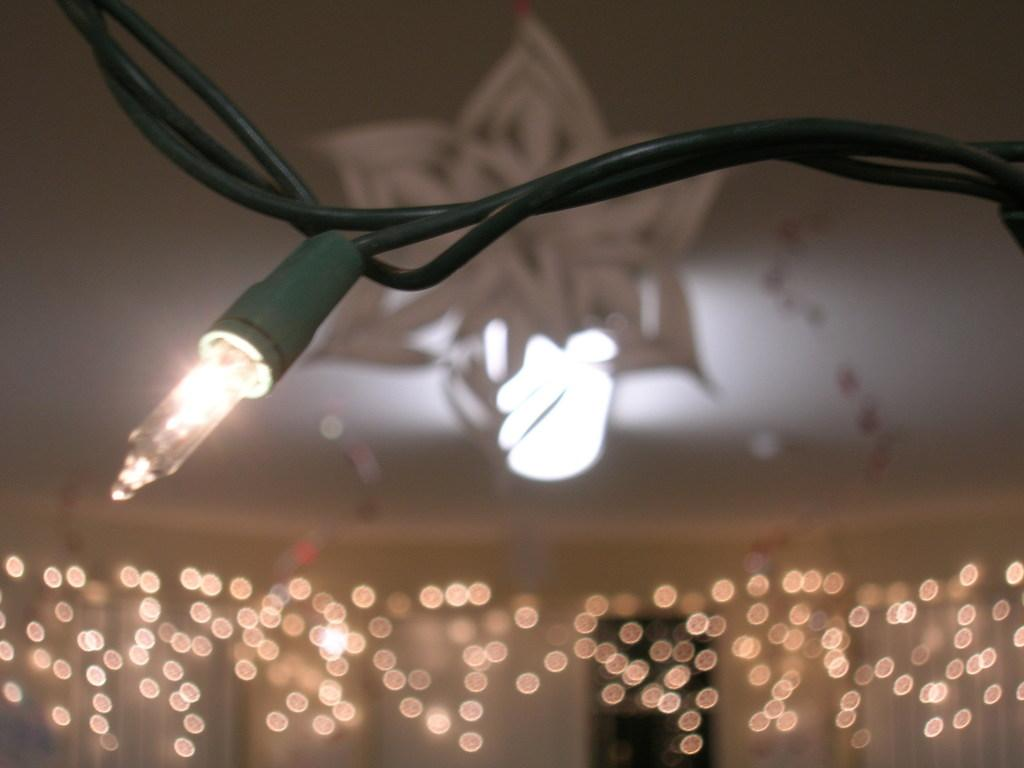What is the main object in the image? There is a light in the image. How is the light connected to other objects? The light is attached to some wires. Are there any other lights visible in the image? Yes, there are additional lights in the image. Can you describe the background of the image? The background of the image is blurry. Is there a comfortable swing in the image? There is no swing present in the image. Can you see a chessboard in the image? There is no chessboard visible in the image. 